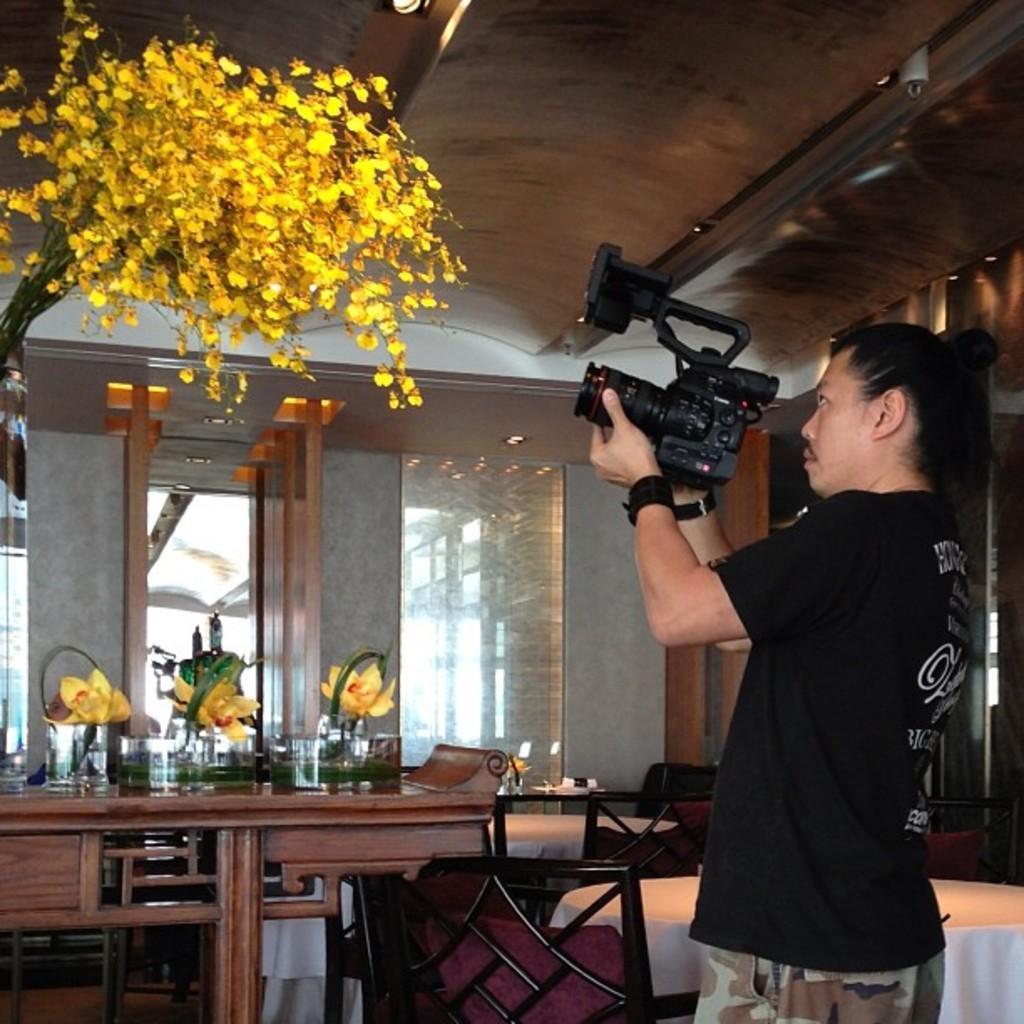Could you give a brief overview of what you see in this image? In the image we can see there is a man who is standing and holding a video camera in his hands and he is shooting the flowers which are in yellow colour. 